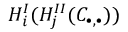Convert formula to latex. <formula><loc_0><loc_0><loc_500><loc_500>H _ { i } ^ { I } ( H _ { j } ^ { I I } ( C _ { \bullet , \bullet } ) )</formula> 